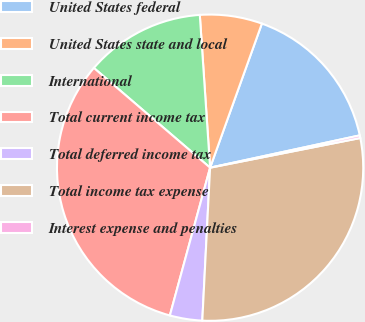Convert chart to OTSL. <chart><loc_0><loc_0><loc_500><loc_500><pie_chart><fcel>United States federal<fcel>United States state and local<fcel>International<fcel>Total current income tax<fcel>Total deferred income tax<fcel>Total income tax expense<fcel>Interest expense and penalties<nl><fcel>16.12%<fcel>6.56%<fcel>12.64%<fcel>32.05%<fcel>3.42%<fcel>28.91%<fcel>0.28%<nl></chart> 